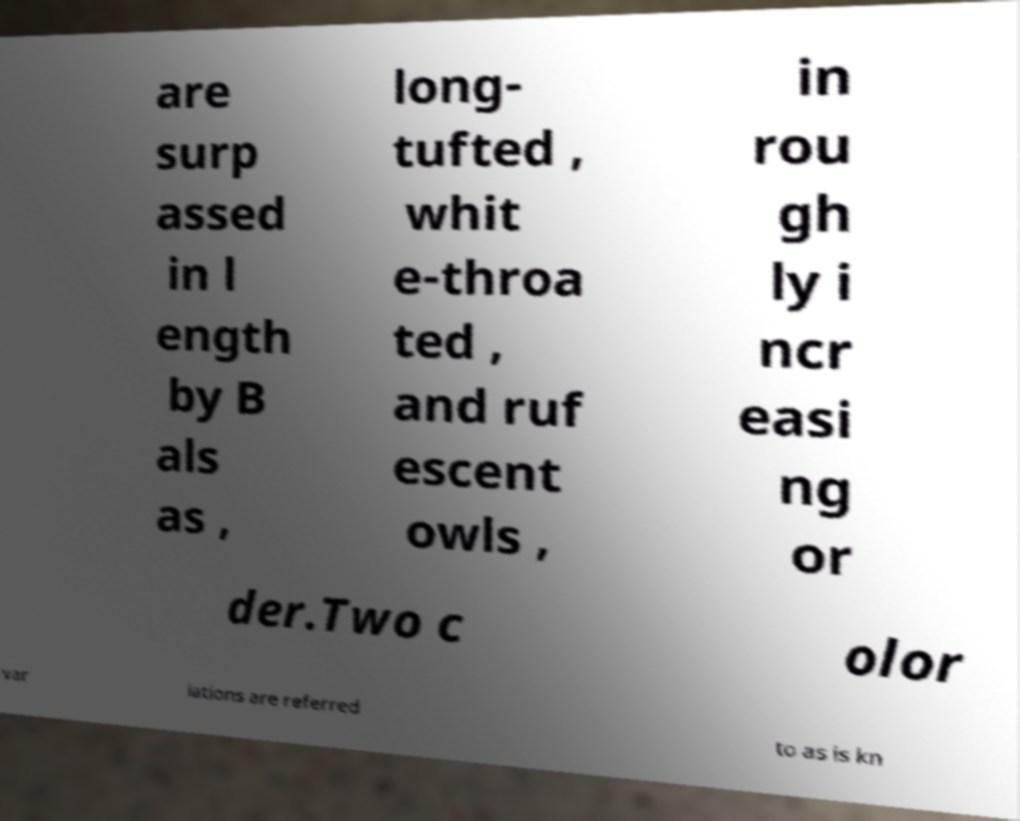What messages or text are displayed in this image? I need them in a readable, typed format. are surp assed in l ength by B als as , long- tufted , whit e-throa ted , and ruf escent owls , in rou gh ly i ncr easi ng or der.Two c olor var iations are referred to as is kn 